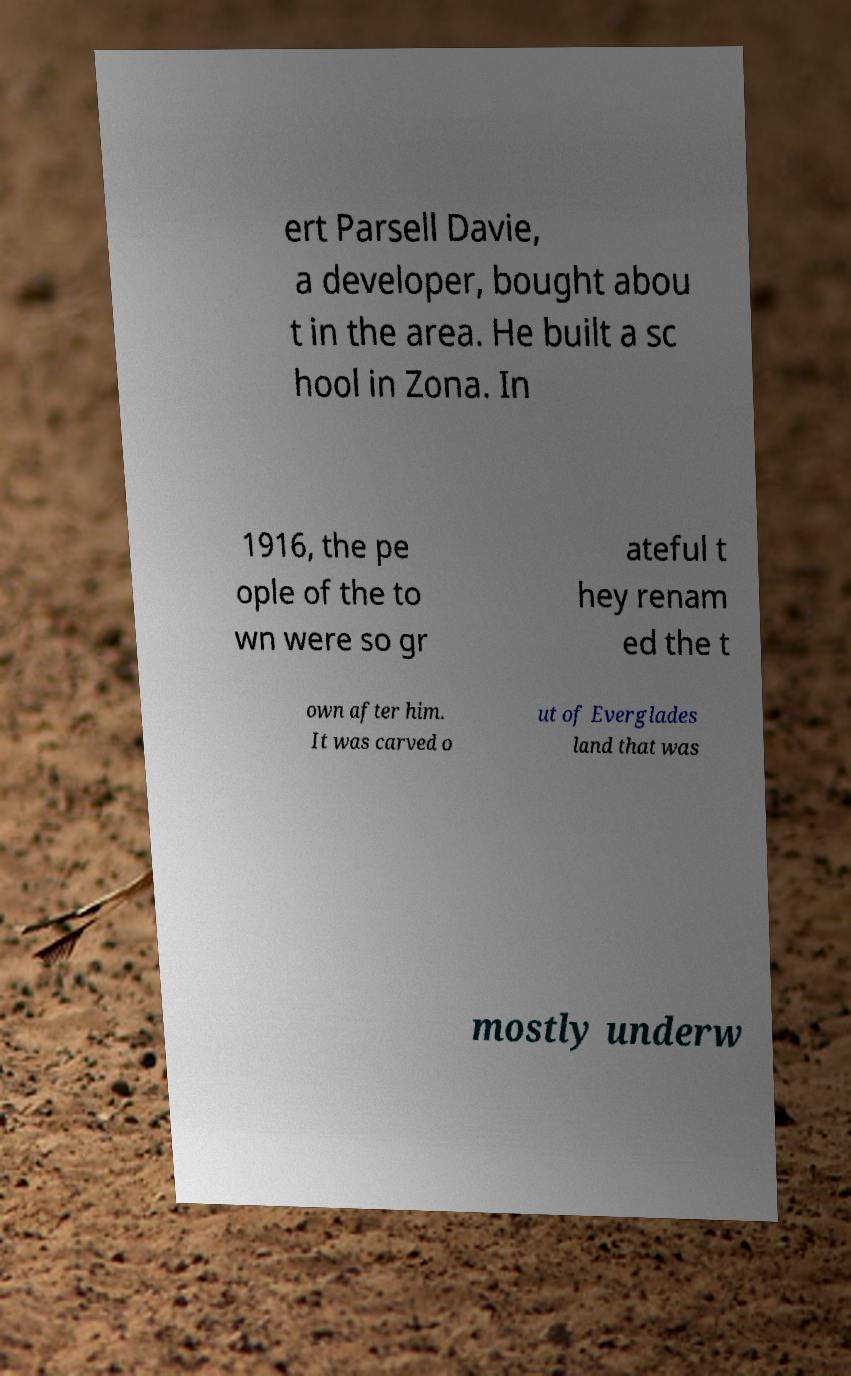Can you read and provide the text displayed in the image?This photo seems to have some interesting text. Can you extract and type it out for me? ert Parsell Davie, a developer, bought abou t in the area. He built a sc hool in Zona. In 1916, the pe ople of the to wn were so gr ateful t hey renam ed the t own after him. It was carved o ut of Everglades land that was mostly underw 